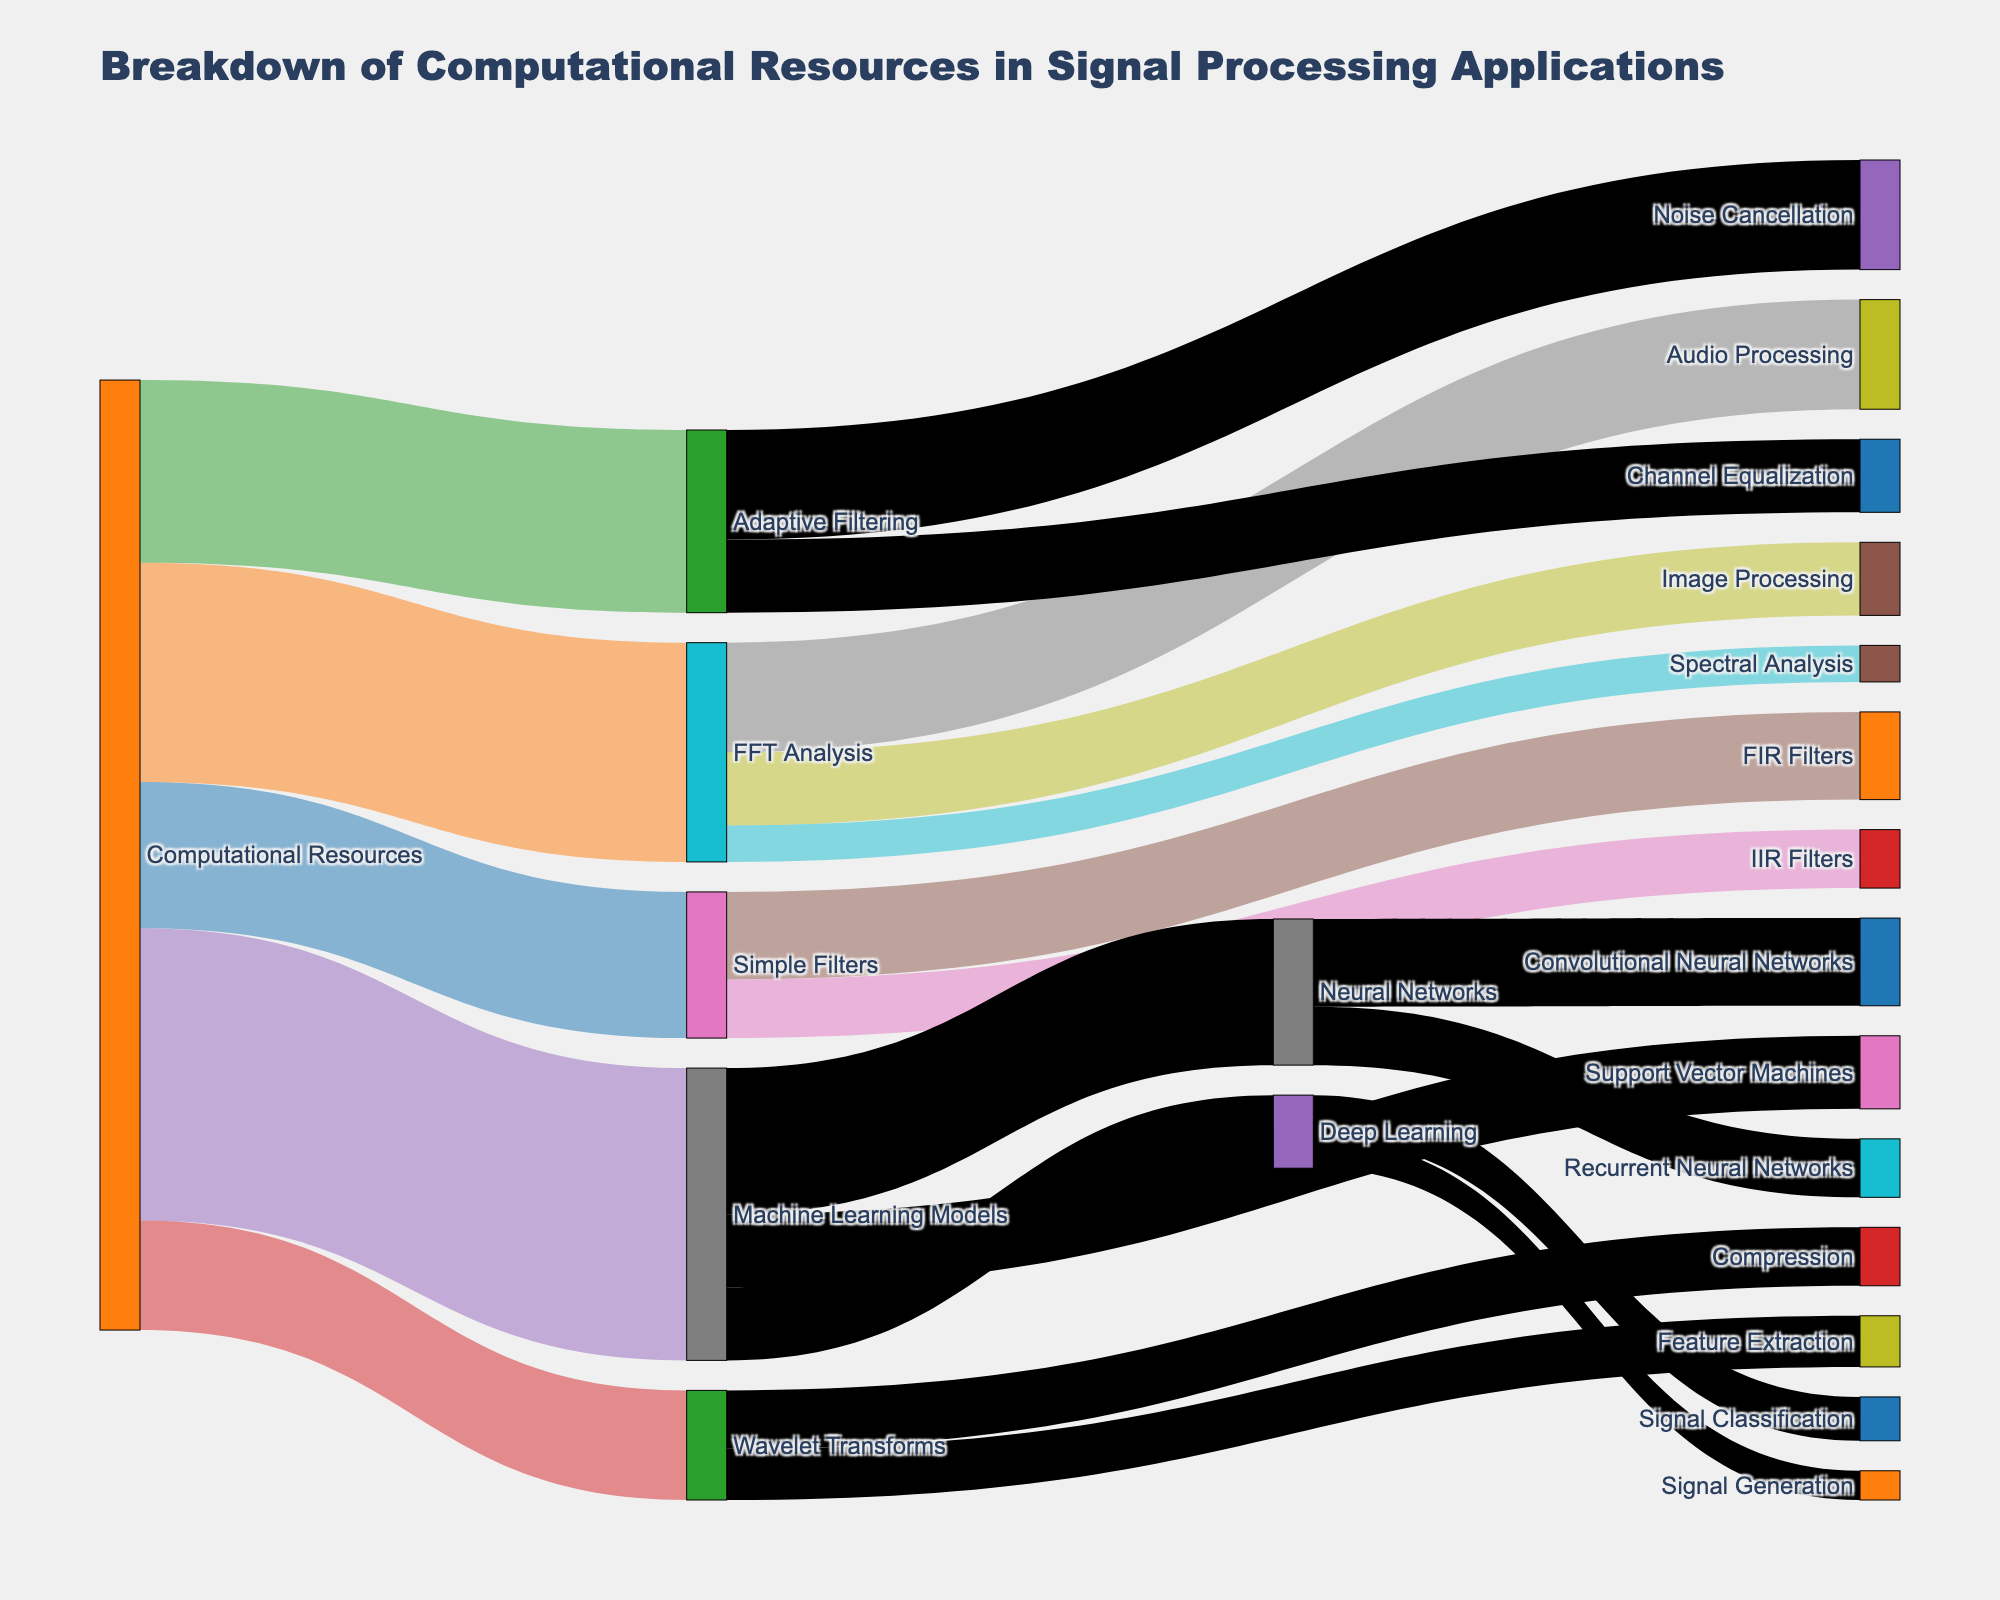What is the title of the figure? The title of the figure can be found at the top of the visual representation. It usually summarizes the main topic or focus of the chart. In this case, it reads "Breakdown of Computational Resources in Signal Processing Applications".
Answer: Breakdown of Computational Resources in Signal Processing Applications Which application uses the most computational resources? To determine which application uses the most computational resources, find the largest value associated with the "Computational Resources" node. The largest value here is 40, and it corresponds to "Machine Learning Models".
Answer: Machine Learning Models How many computational resources are used for FFT Analysis and Wavelet Transforms combined? To find the total computational resources used by FFT Analysis and Wavelet Transforms, simply add their respective values from the chart. FFT Analysis uses 30 and Wavelet Transforms uses 15. So, 30 + 15 = 45.
Answer: 45 Which application under "Machine Learning Models" uses the least computational resources? Look at the individual applications under the "Machine Learning Models" node. Compare the values: Neural Networks (20), Support Vector Machines (10), and Deep Learning (10). The least computational resources are used by the Support Vector Machines and Deep Learning, each with a value of 10.
Answer: Support Vector Machines and Deep Learning What percentage of computational resources are allocated to Adaptive Filtering out of the total resources? First, sum the total computational resources: 20 (Simple Filters) + 30 (FFT Analysis) + 25 (Adaptive Filtering) + 15 (Wavelet Transforms) + 40 (Machine Learning Models) = 130. Then, calculate the percentage for Adaptive Filtering: (25/130) * 100 ≈ 19.23%.
Answer: 19.23% Compare the computational resources used by FIR Filters and IIR Filters. Which one uses more and by how much? Look at the values under "Simple Filters": FIR Filters (12) and IIR Filters (8). The difference is 12 - 8 = 4. FIR Filters use 4 more resources than IIR Filters.
Answer: FIR Filters by 4 What is the total flow through the "Neural Networks" node? To determine the total flow through the "Neural Networks" node, sum up the values of the nodes connected to it: Convolutional Neural Networks (12) + Recurrent Neural Networks (8). Therefore, the total flow is 20.
Answer: 20 Which specific task under Deep Learning uses fewer resources? Look at the nodes under "Deep Learning": Signal Classification (6) and Signal Generation (4). The task that uses fewer resources is Signal Generation with a value of 4.
Answer: Signal Generation How does the computational resource allocation for Noise Cancellation compare with that for Channel Equalization? Find the values for both: Noise Cancellation (15) and Channel Equalization (10). Noise Cancellation uses more resources than Channel Equalization by a difference of 5.
Answer: Noise Cancellation by 5 If computational resources for Wavelet Transforms were increased by 10, what would be the new total computational resources? Current total resources are 130. Adding 10 more to Wavelet Transforms' initial 15 would give it 25. Therefore, the new total is 130 + 10 = 140.
Answer: 140 